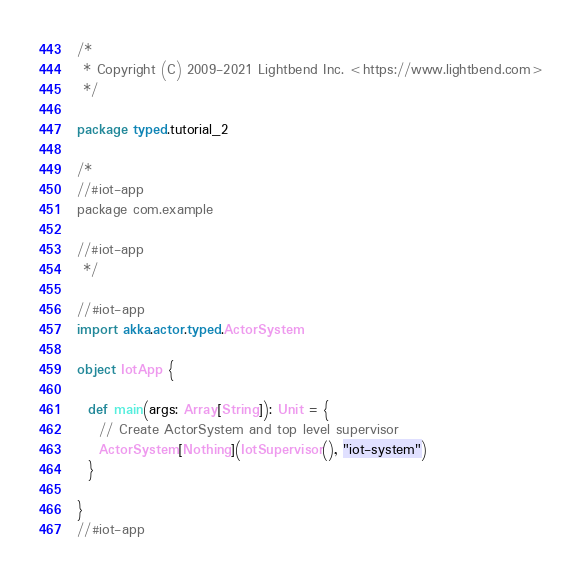<code> <loc_0><loc_0><loc_500><loc_500><_Scala_>/*
 * Copyright (C) 2009-2021 Lightbend Inc. <https://www.lightbend.com>
 */

package typed.tutorial_2

/*
//#iot-app
package com.example

//#iot-app
 */

//#iot-app
import akka.actor.typed.ActorSystem

object IotApp {

  def main(args: Array[String]): Unit = {
    // Create ActorSystem and top level supervisor
    ActorSystem[Nothing](IotSupervisor(), "iot-system")
  }

}
//#iot-app
</code> 